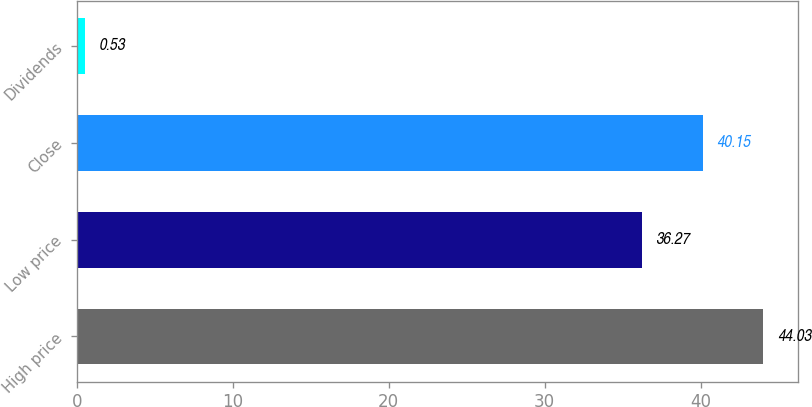Convert chart. <chart><loc_0><loc_0><loc_500><loc_500><bar_chart><fcel>High price<fcel>Low price<fcel>Close<fcel>Dividends<nl><fcel>44.03<fcel>36.27<fcel>40.15<fcel>0.53<nl></chart> 